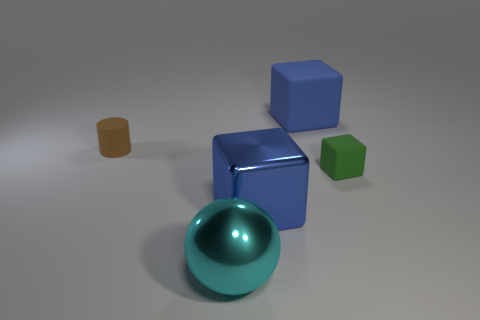Add 4 blue metallic blocks. How many objects exist? 9 Subtract all large blocks. How many blocks are left? 1 Subtract 1 cubes. How many cubes are left? 2 Subtract all red cylinders. How many cyan cubes are left? 0 Subtract all cyan metallic balls. Subtract all rubber things. How many objects are left? 1 Add 5 large balls. How many large balls are left? 6 Add 4 tiny green things. How many tiny green things exist? 5 Subtract all blue blocks. How many blocks are left? 1 Subtract 0 red balls. How many objects are left? 5 Subtract all cubes. How many objects are left? 2 